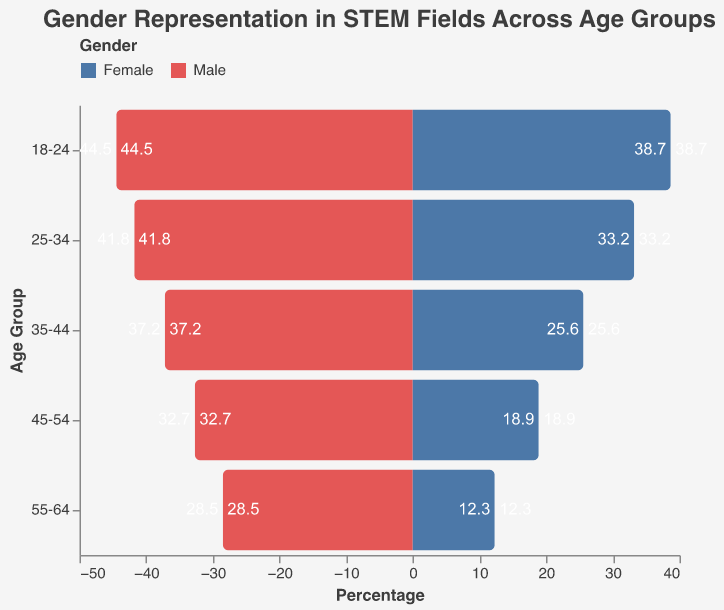What is the title of the figure? The title of the figure is displayed at the top. It reads "Gender Representation in STEM Fields Across Age Groups".
Answer: Gender Representation in STEM Fields Across Age Groups How many age groups are represented in the figure? To determine the number of age groups, count the distinct age groups listed along the vertical axis. They are: 55-64, 45-54, 35-44, 25-34, and 18-24.
Answer: 5 Which age group has the highest percentage of males in STEM fields? Refer to the horizontal bars on the left side of the figure. The age group 18-24 has the longest bar representing 44.5%, which is the highest percentage.
Answer: 18-24 What is the percentage difference between males and females in the 45-54 age group? By looking at the bars for the 45-54 age group, the male percentage is 32.7% and the female percentage is 18.9%. The difference is 32.7% - 18.9% = 13.8%.
Answer: 13.8% Which age group shows the smallest gender gap in STEM fields? Examine the bars for each age group and find the one with the smallest difference between male and female percentages. The 18-24 age group has males at 44.5% and females at 38.7%, with a difference of 44.5% - 38.7% = 5.8%, which is the smallest gap.
Answer: 18-24 What is the approximate average percentage of females across all age groups? The female percentages are 12.3%, 18.9%, 25.6%, 33.2%, and 38.7%. Sum these values (12.3 + 18.9 + 25.6 + 33.2 + 38.7 = 128.7) and divide by the number of age groups (5). The average is 128.7/5 = 25.74%.
Answer: 25.74% How does the male percentage for the 25-34 age group compare to the male percentage for the 55-64 age group? The male percentage for 25-34 is 41.8%, and for 55-64, it is 28.5%. 41.8% is greater than 28.5%.
Answer: 41.8% is greater than 28.5% In which age group do females have the lowest representation in STEM fields? By looking at the horizontal bars on the right side of the figure, the age group 55-64 has the shortest bar for females, which is 12.3%.
Answer: 55-64 How much greater is the male percentage than the female percentage in the 35-44 age group? The male percentage in 35-44 is 37.2%, and the female percentage is 25.6%. The difference is 37.2% - 25.6% = 11.6%.
Answer: 11.6% 